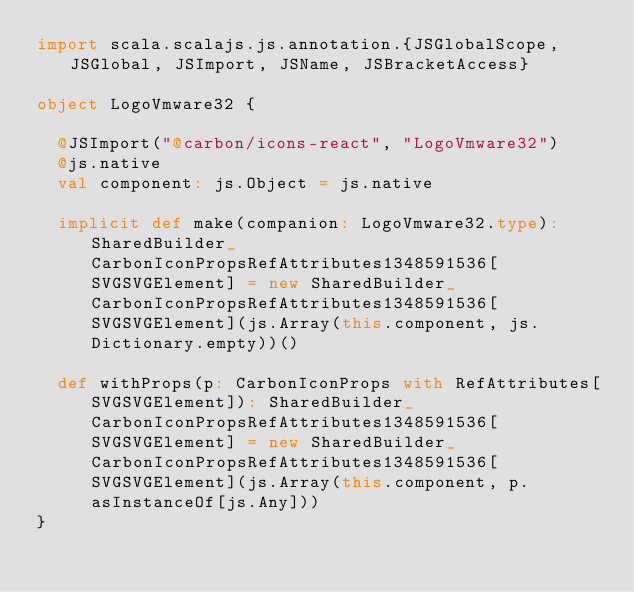Convert code to text. <code><loc_0><loc_0><loc_500><loc_500><_Scala_>import scala.scalajs.js.annotation.{JSGlobalScope, JSGlobal, JSImport, JSName, JSBracketAccess}

object LogoVmware32 {
  
  @JSImport("@carbon/icons-react", "LogoVmware32")
  @js.native
  val component: js.Object = js.native
  
  implicit def make(companion: LogoVmware32.type): SharedBuilder_CarbonIconPropsRefAttributes1348591536[SVGSVGElement] = new SharedBuilder_CarbonIconPropsRefAttributes1348591536[SVGSVGElement](js.Array(this.component, js.Dictionary.empty))()
  
  def withProps(p: CarbonIconProps with RefAttributes[SVGSVGElement]): SharedBuilder_CarbonIconPropsRefAttributes1348591536[SVGSVGElement] = new SharedBuilder_CarbonIconPropsRefAttributes1348591536[SVGSVGElement](js.Array(this.component, p.asInstanceOf[js.Any]))
}
</code> 